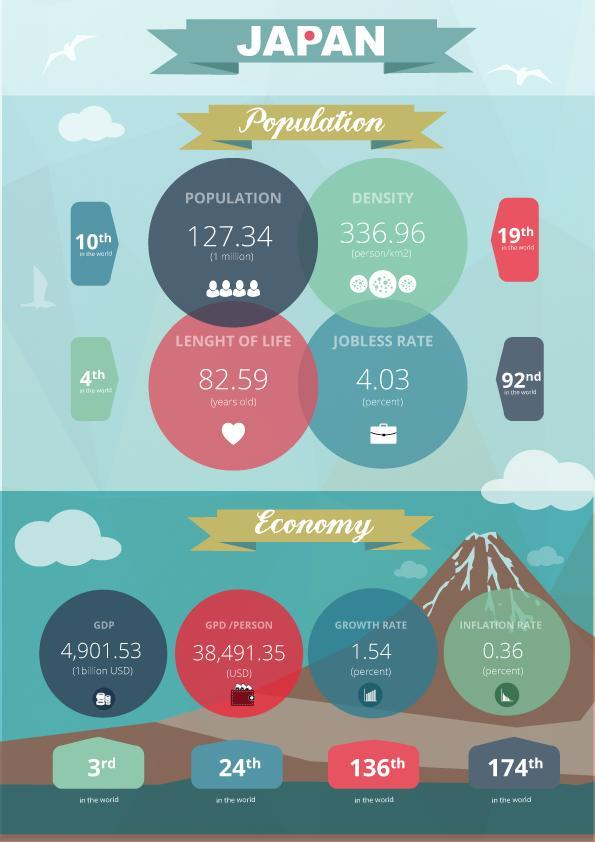What is the jobless rate in Japan?
Answer the question with a short phrase. 4.03 What is the life expectancy of Japan? 82.59 What is the GDP of Japan? 4,901.53 